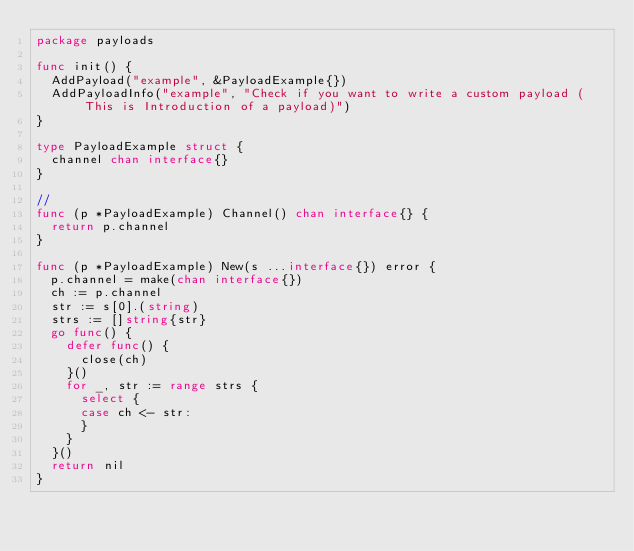Convert code to text. <code><loc_0><loc_0><loc_500><loc_500><_Go_>package payloads

func init() {
	AddPayload("example", &PayloadExample{})
	AddPayloadInfo("example", "Check if you want to write a custom payload (This is Introduction of a payload)")
}

type PayloadExample struct {
	channel chan interface{}
}

//
func (p *PayloadExample) Channel() chan interface{} {
	return p.channel
}

func (p *PayloadExample) New(s ...interface{}) error {
	p.channel = make(chan interface{})
	ch := p.channel
	str := s[0].(string)
	strs := []string{str}
	go func() {
		defer func() {
			close(ch)
		}()
		for _, str := range strs {
			select {
			case ch <- str:
			}
		}
	}()
	return nil
}
</code> 